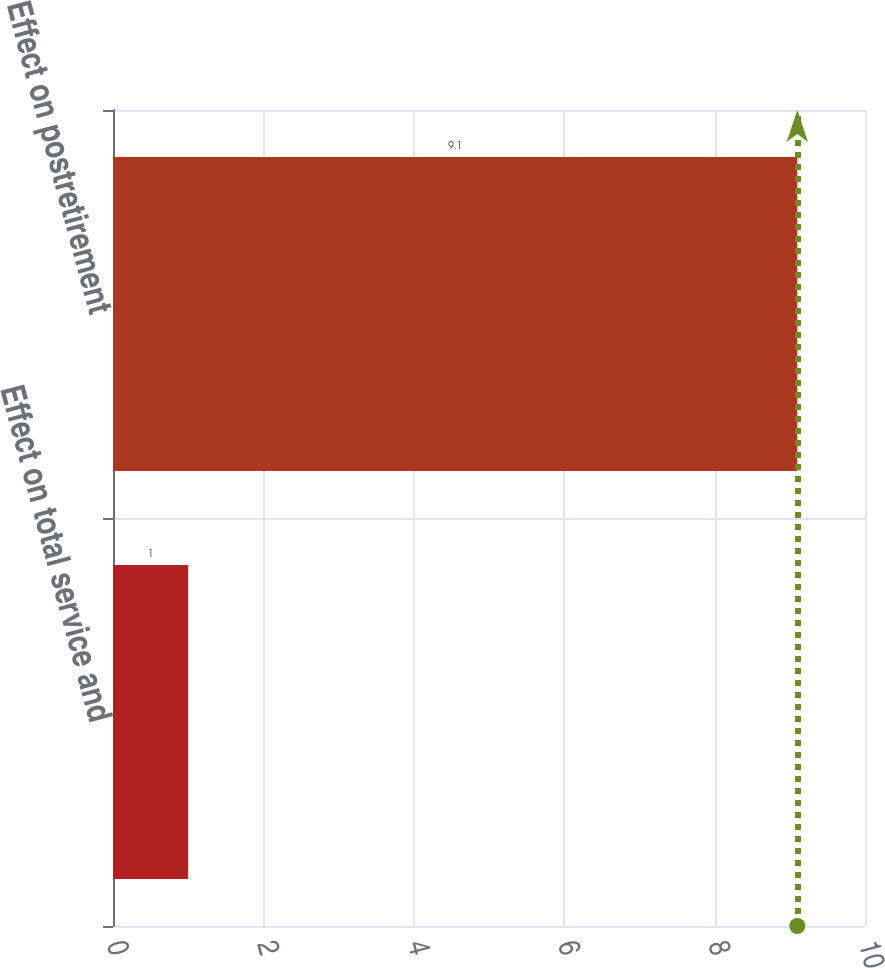Convert chart. <chart><loc_0><loc_0><loc_500><loc_500><bar_chart><fcel>Effect on total service and<fcel>Effect on postretirement<nl><fcel>1<fcel>9.1<nl></chart> 